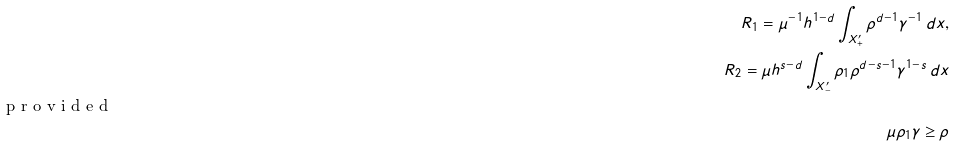Convert formula to latex. <formula><loc_0><loc_0><loc_500><loc_500>R _ { 1 } = \mu ^ { - 1 } h ^ { 1 - d } \int _ { X ^ { \prime } _ { + } } \rho ^ { d - 1 } \gamma ^ { - 1 } \, d x , \\ R _ { 2 } = \mu h ^ { s - d } \int _ { X ^ { \prime } _ { - } } \rho _ { 1 } \rho ^ { d - s - 1 } \gamma ^ { 1 - s } \, d x \shortintertext { p r o v i d e d } \mu \rho _ { 1 } \gamma \geq \rho</formula> 